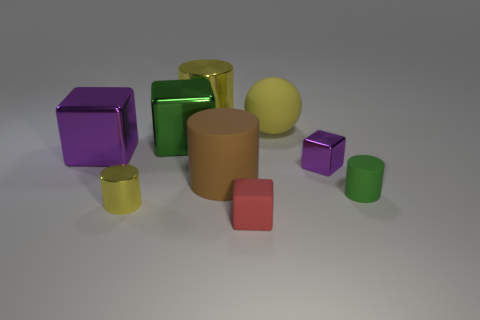What shape is the small object that is both behind the small yellow metallic cylinder and in front of the small purple metallic block?
Provide a succinct answer. Cylinder. There is a big shiny cylinder; is its color the same as the shiny cylinder that is in front of the green matte thing?
Provide a succinct answer. Yes. Do the rubber object that is in front of the green rubber cylinder and the rubber ball have the same size?
Offer a very short reply. No. There is a green thing that is the same shape as the brown rubber object; what material is it?
Keep it short and to the point. Rubber. Does the large green thing have the same shape as the large brown object?
Provide a short and direct response. No. How many small rubber blocks are to the left of the green thing that is behind the brown rubber object?
Offer a terse response. 0. There is a small object that is the same material as the tiny green cylinder; what shape is it?
Keep it short and to the point. Cube. How many blue things are either tiny metal things or large rubber cylinders?
Provide a succinct answer. 0. There is a yellow cylinder that is left of the metallic thing that is behind the big yellow rubber ball; is there a red rubber cube on the left side of it?
Ensure brevity in your answer.  No. Are there fewer small objects than large brown objects?
Offer a terse response. No. 